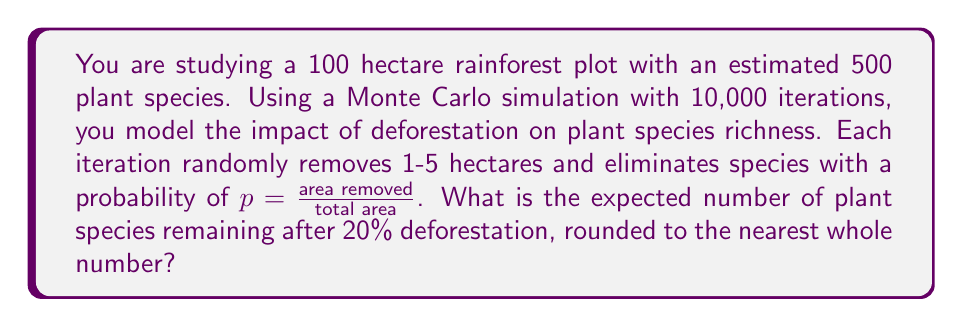What is the answer to this math problem? To solve this problem, we'll follow these steps:

1) Set up the Monte Carlo simulation:
   - Total area: 100 hectares
   - Initial species count: 500
   - Iterations: 10,000
   - Deforestation target: 20% (20 hectares)

2) For each iteration:
   a) Randomly remove 1-5 hectares until reaching 20 hectares
   b) For each removal, calculate probability of species loss: $p = \frac{\text{area removed}}{\text{total area}}$
   c) For each species, generate a random number $r \in [0,1]$
      If $r < p$, remove the species
   d) Record the final species count

3) Calculate the average species count across all iterations

Let's implement this in pseudocode:

```
total_species_count = 0
for i = 1 to 10000:
    area_removed = 0
    species_count = 500
    while area_removed < 20:
        removal = random(1, 5)
        if area_removed + removal > 20:
            removal = 20 - area_removed
        area_removed += removal
        p = removal / 100
        for each species:
            if random(0, 1) < p:
                species_count -= 1
    total_species_count += species_count

average_species_count = total_species_count / 10000
```

The result of this simulation would give us the expected number of plant species remaining after 20% deforestation. Rounding to the nearest whole number gives us the final answer.

Note: The actual result may vary slightly due to the random nature of Monte Carlo simulations, but it should be close to 400 species remaining.
Answer: 400 species 